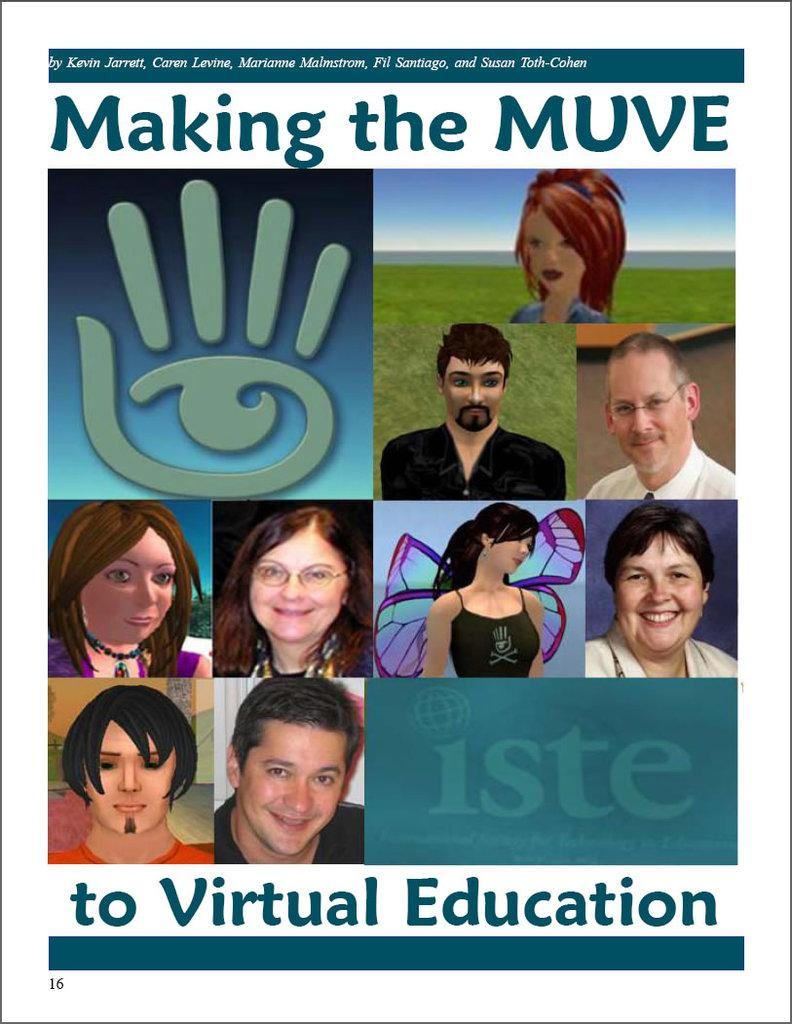What is present on the poster in the image? There is a poster in the image. What can be found on the poster besides images? The poster contains text. What type of images are on the poster? The poster has animated images. How many pictures are on the poster? There are four pictures on the poster. What is the texture of the hand holding the poster in the image? There is no hand holding the poster in the image; it is not mentioned in the provided facts. 